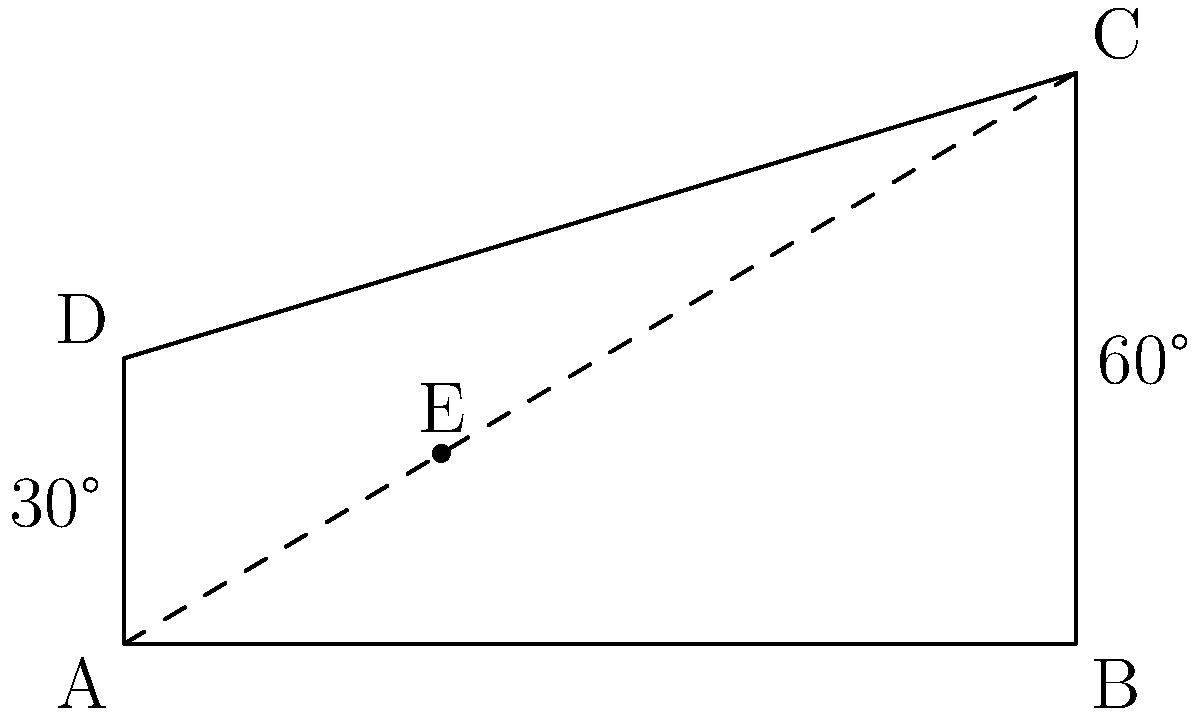In our textile mill, we're considering installing two new conveyor belts that will intersect. The first belt runs from point A to C, while the second belt runs from B to D. If the angle between the horizontal and the first belt is 30°, and the angle between the horizontal and the second belt is 60°, what is the angle of intersection between these two conveyor belts? Let's approach this step-by-step:

1) First, we need to understand that the angle of intersection between the two conveyor belts is the same as the angle between the lines AC and BD.

2) In a plane, when two lines intersect, the adjacent angles are supplementary (they add up to 180°).

3) Let's call the angle of intersection $x$. Then, the other angle formed at the intersection point is $(180° - x)$.

4) Now, we can use the fact that the sum of the angles in a triangle is always 180°.

5) Looking at the triangle formed by the intersection point (let's call it E) and points A and B:
   
   $\angle AEB + 30° + 60° = 180°$

6) We know that $\angle AEB = (180° - x)$ from step 3.

7) Substituting this in:
   
   $(180° - x) + 30° + 60° = 180°$

8) Simplifying:
   
   $270° - x = 180°$

9) Solving for $x$:
   
   $x = 270° - 180° = 90°$

Therefore, the angle of intersection between the two conveyor belts is 90°.
Answer: 90° 